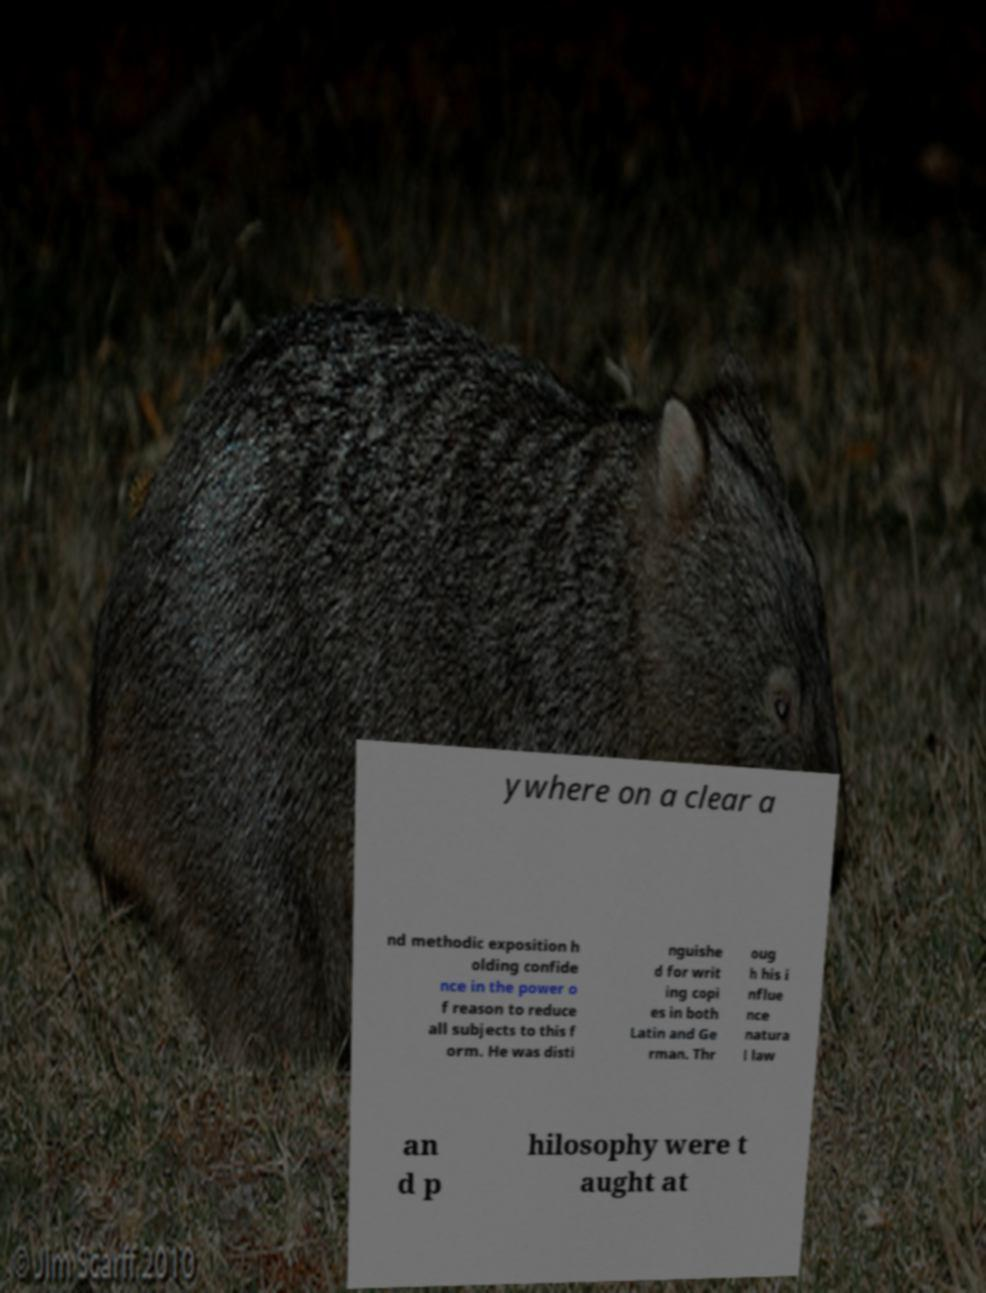There's text embedded in this image that I need extracted. Can you transcribe it verbatim? ywhere on a clear a nd methodic exposition h olding confide nce in the power o f reason to reduce all subjects to this f orm. He was disti nguishe d for writ ing copi es in both Latin and Ge rman. Thr oug h his i nflue nce natura l law an d p hilosophy were t aught at 